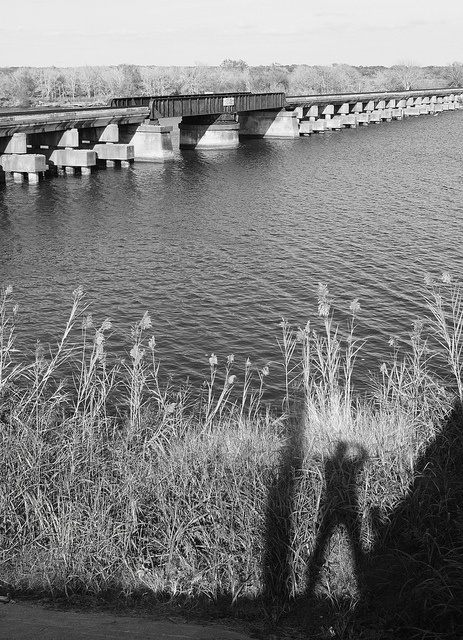Describe the objects in this image and their specific colors. I can see various objects in this image with different colors. 